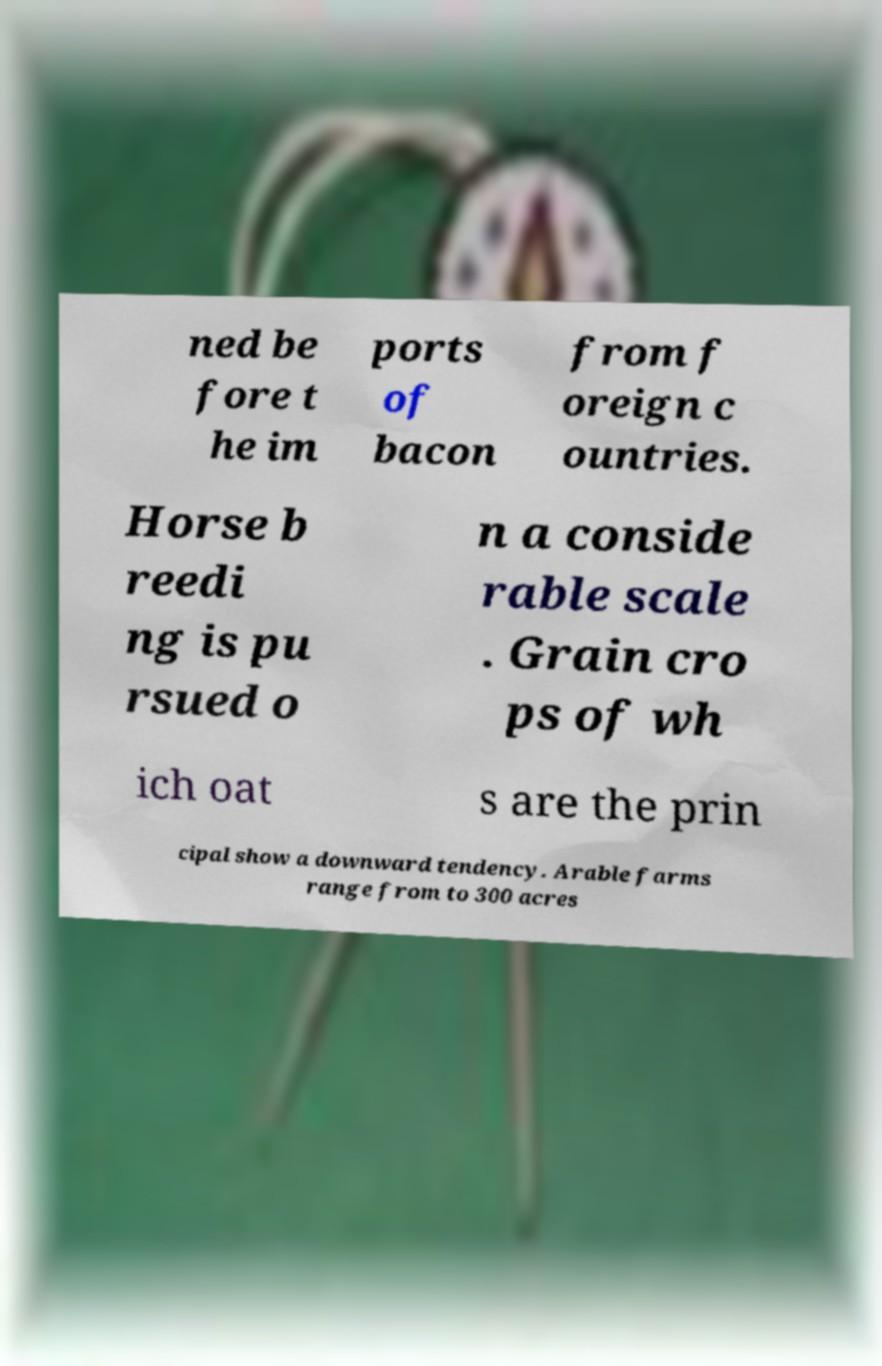Can you accurately transcribe the text from the provided image for me? ned be fore t he im ports of bacon from f oreign c ountries. Horse b reedi ng is pu rsued o n a conside rable scale . Grain cro ps of wh ich oat s are the prin cipal show a downward tendency. Arable farms range from to 300 acres 